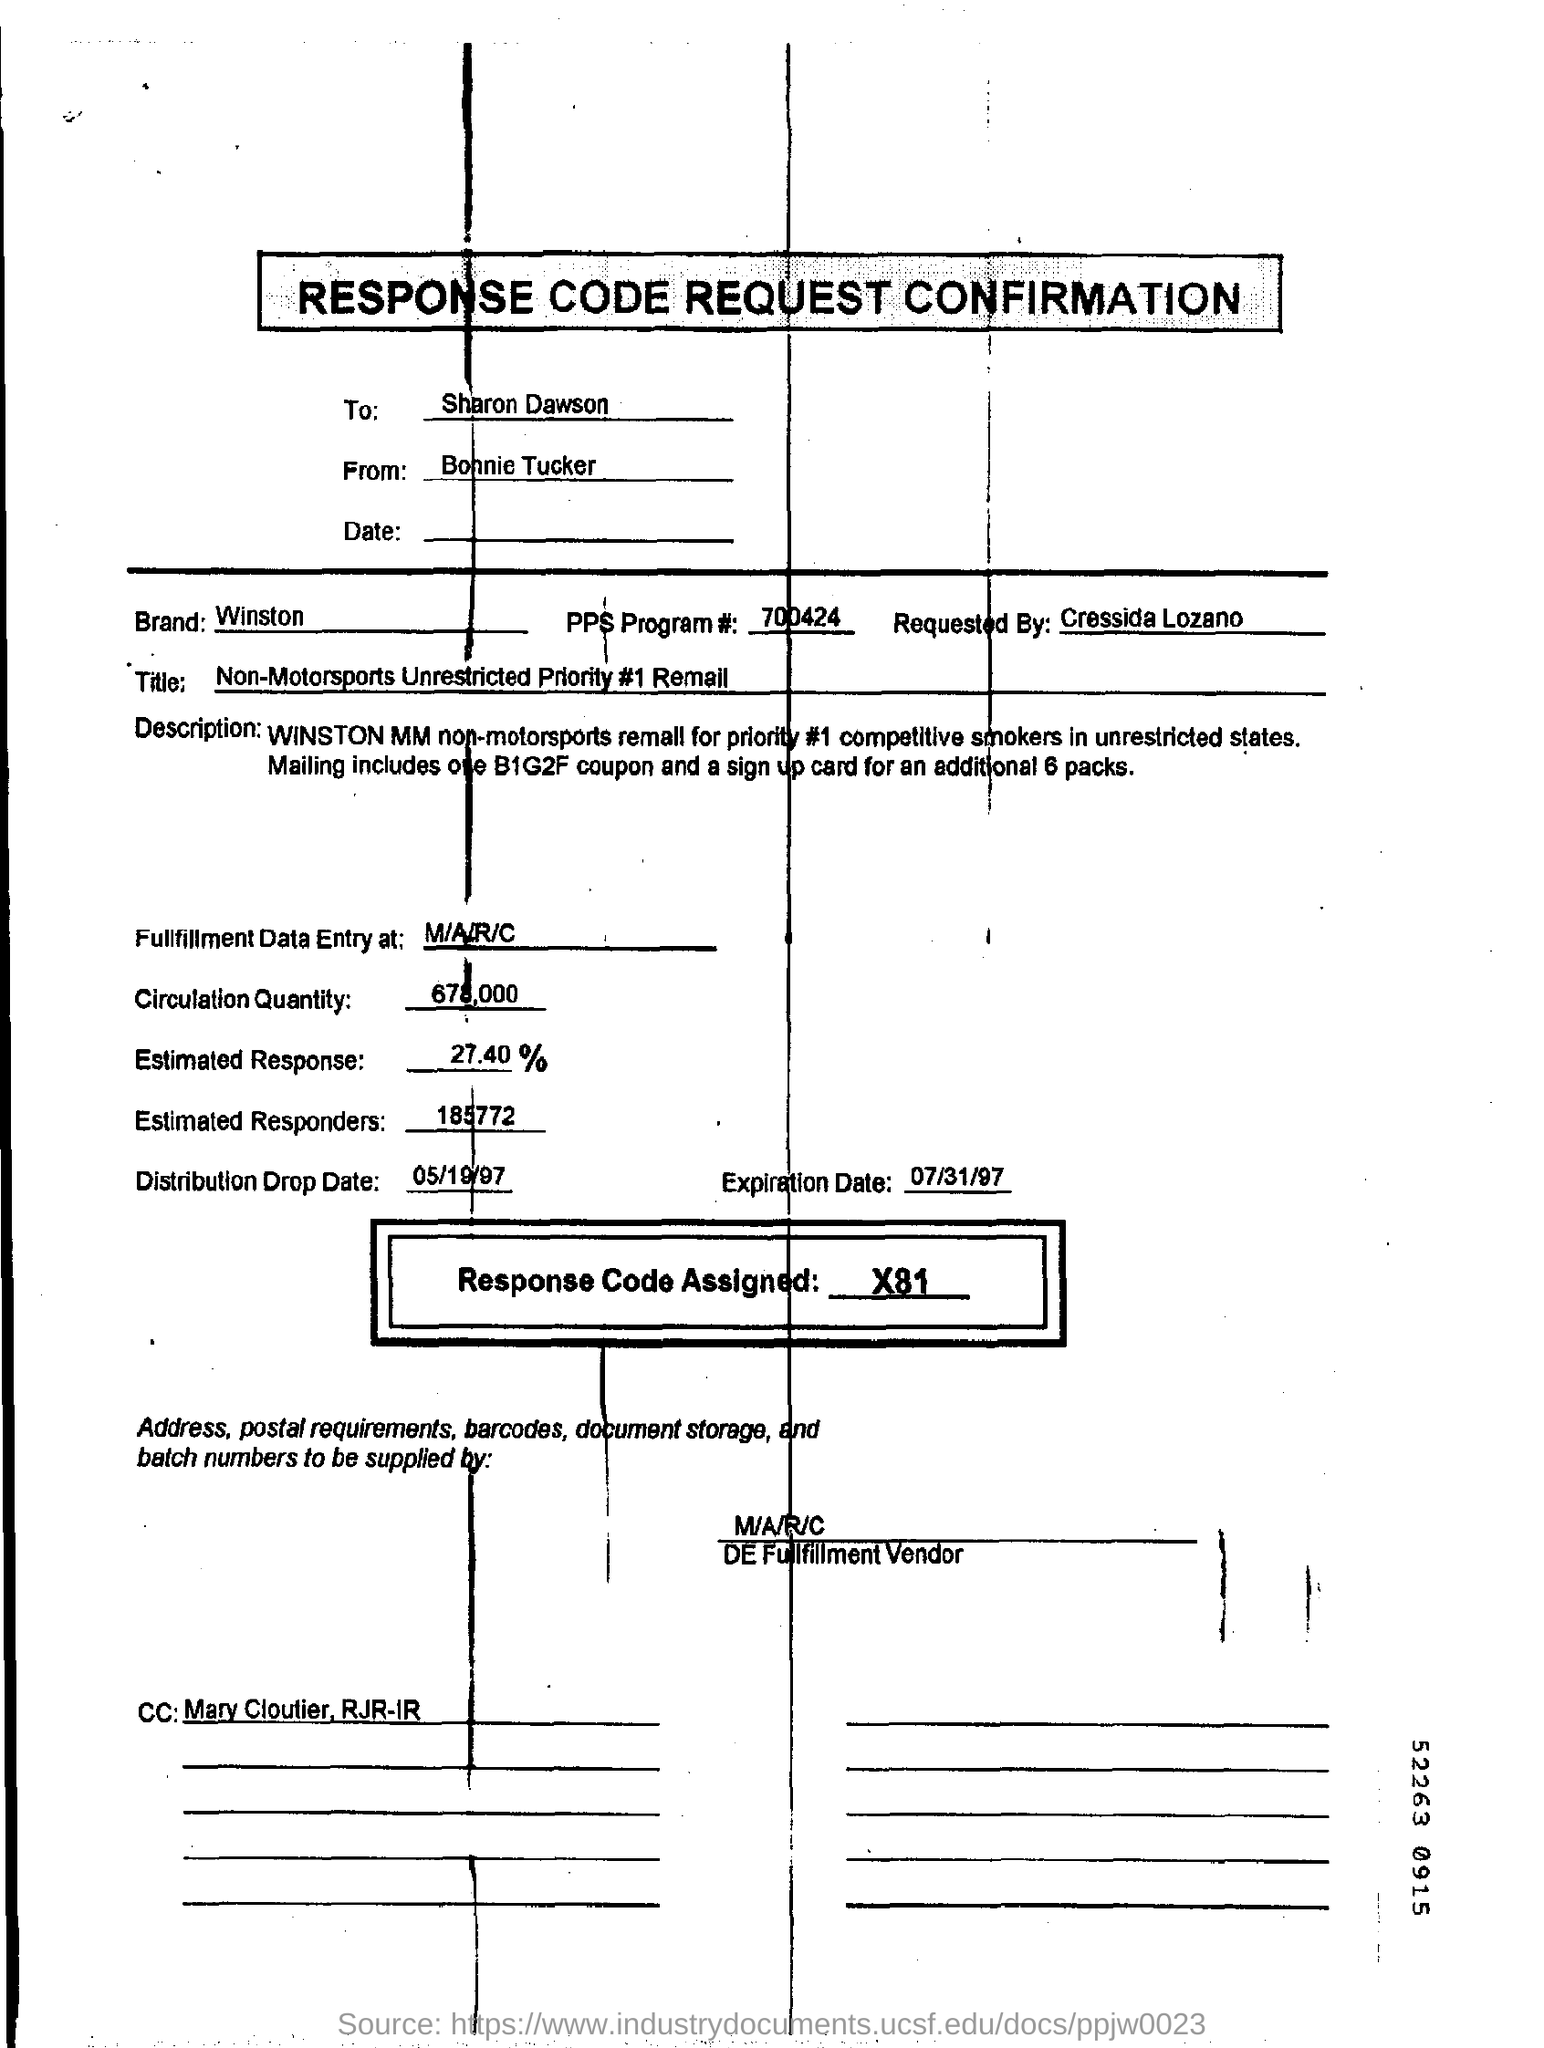List a handful of essential elements in this visual. The code of the PPS program is 700424. Bonnie Tucker is the sender of the response code request confirmation. 